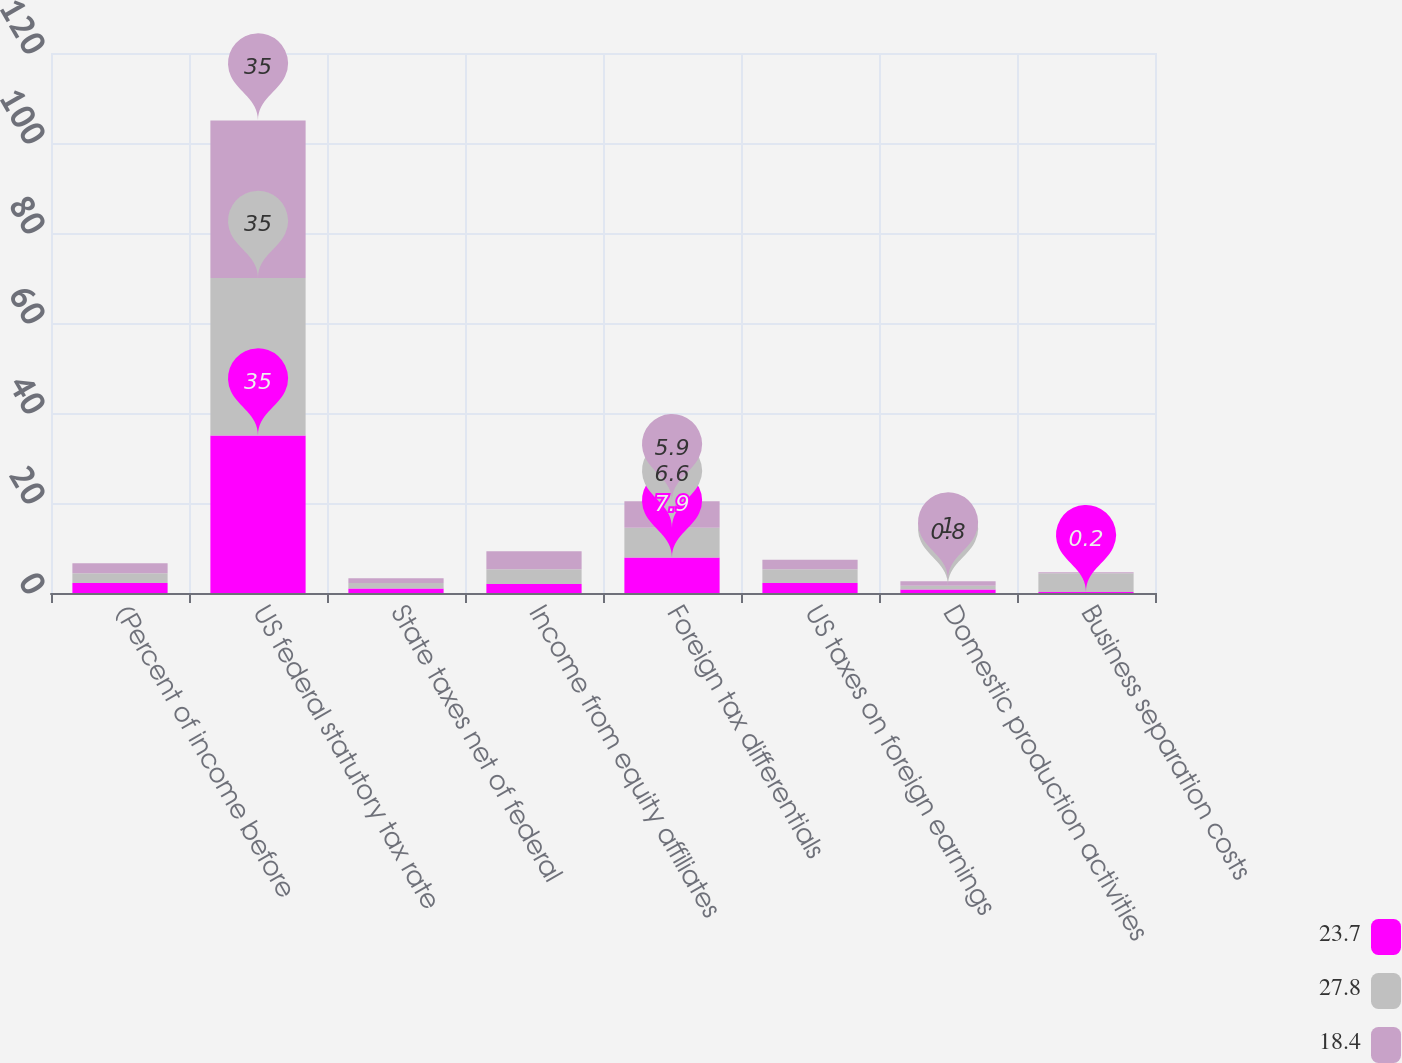Convert chart to OTSL. <chart><loc_0><loc_0><loc_500><loc_500><stacked_bar_chart><ecel><fcel>(Percent of income before<fcel>US federal statutory tax rate<fcel>State taxes net of federal<fcel>Income from equity affiliates<fcel>Foreign tax differentials<fcel>US taxes on foreign earnings<fcel>Domestic production activities<fcel>Business separation costs<nl><fcel>23.7<fcel>2.2<fcel>35<fcel>1<fcel>2<fcel>7.9<fcel>2.2<fcel>0.8<fcel>0.2<nl><fcel>27.8<fcel>2.2<fcel>35<fcel>1.2<fcel>3.3<fcel>6.6<fcel>3.1<fcel>0.8<fcel>4.2<nl><fcel>18.4<fcel>2.2<fcel>35<fcel>1.1<fcel>4<fcel>5.9<fcel>2.1<fcel>1<fcel>0.2<nl></chart> 